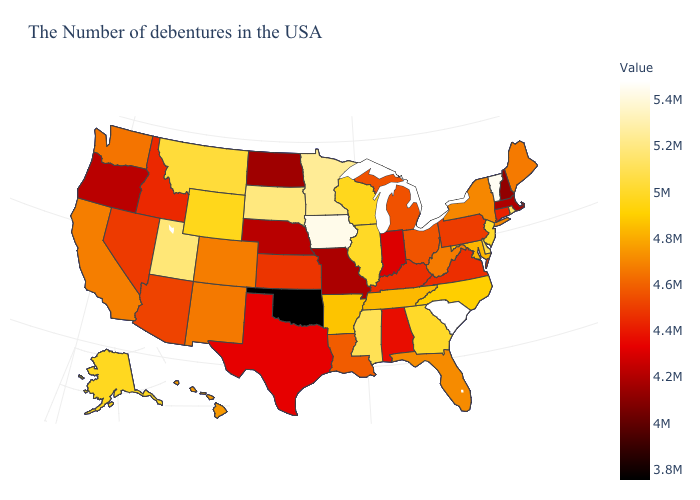Which states hav the highest value in the Northeast?
Write a very short answer. Vermont. Among the states that border Delaware , which have the highest value?
Quick response, please. New Jersey. Among the states that border Louisiana , does Texas have the highest value?
Answer briefly. No. Does South Carolina have the highest value in the USA?
Give a very brief answer. Yes. Which states have the lowest value in the USA?
Be succinct. Oklahoma. Among the states that border Idaho , which have the highest value?
Quick response, please. Utah. Which states have the lowest value in the MidWest?
Concise answer only. North Dakota. Does Tennessee have a higher value than Minnesota?
Write a very short answer. No. 